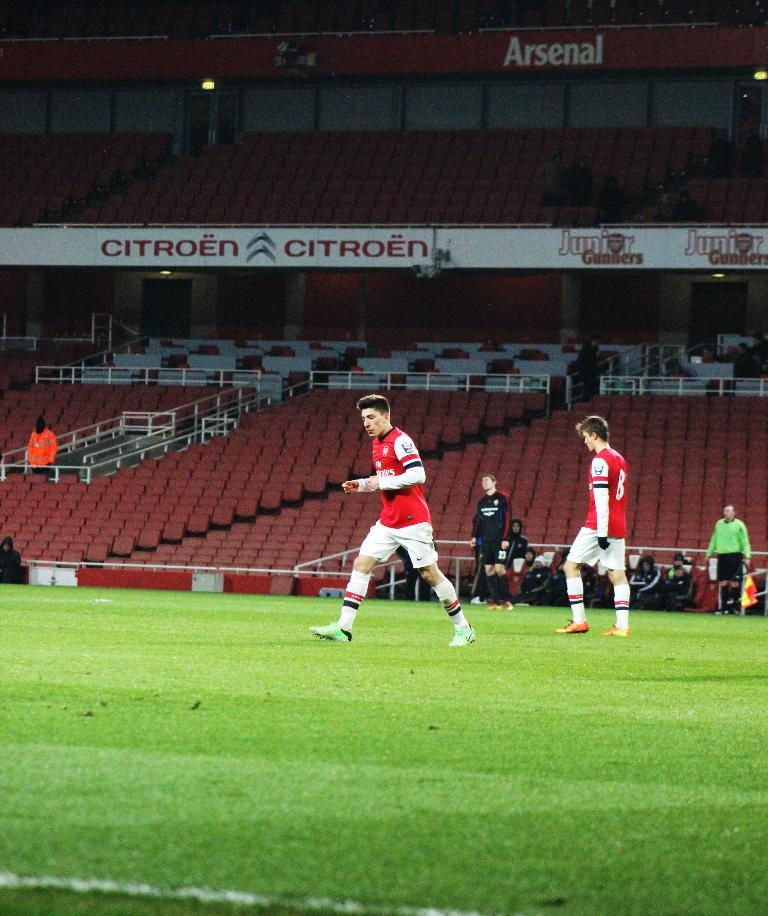<image>
Write a terse but informative summary of the picture. soccer players on an Arsenal field with Citroen ads 